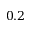<formula> <loc_0><loc_0><loc_500><loc_500>0 . 2</formula> 